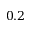<formula> <loc_0><loc_0><loc_500><loc_500>0 . 2</formula> 